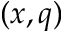Convert formula to latex. <formula><loc_0><loc_0><loc_500><loc_500>( x , q )</formula> 